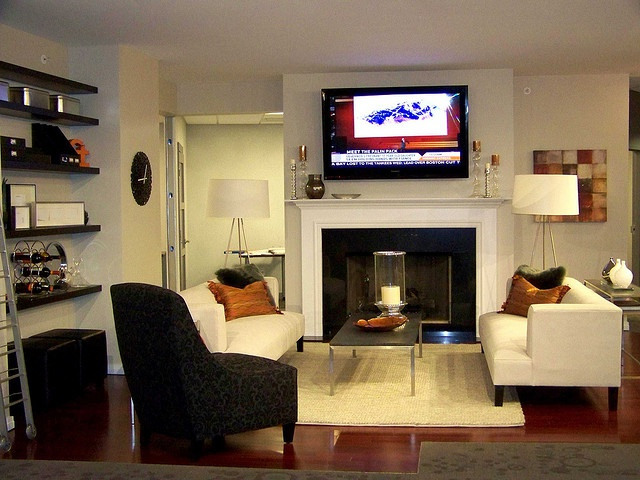Describe the objects in this image and their specific colors. I can see chair in black and gray tones, couch in black, tan, khaki, and maroon tones, tv in black, white, brown, and maroon tones, couch in black, tan, and brown tones, and clock in black, tan, and gray tones in this image. 